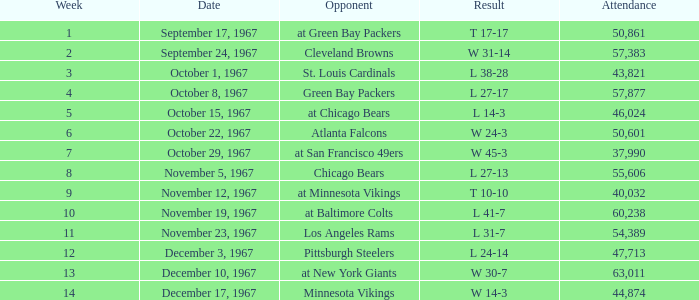Which Date has a Week smaller than 8, and an Opponent of atlanta falcons? October 22, 1967. 